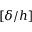Convert formula to latex. <formula><loc_0><loc_0><loc_500><loc_500>[ \delta / h ]</formula> 